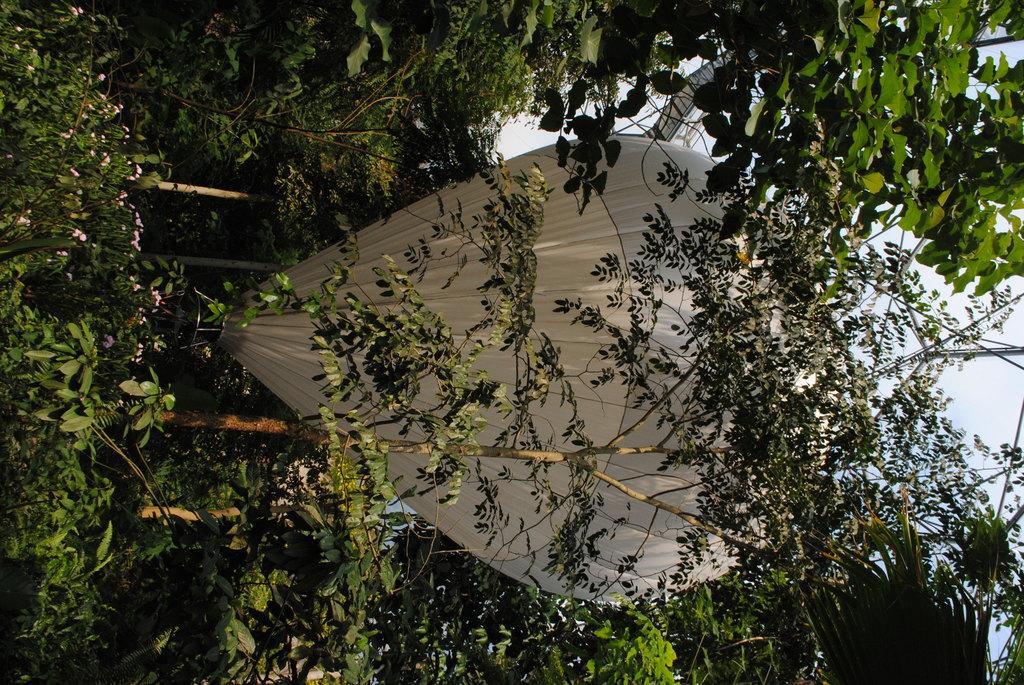Can you describe this image briefly? In this picture we can see plants, flowers, trees and paragliding. In the background of the image we can see the sky. 